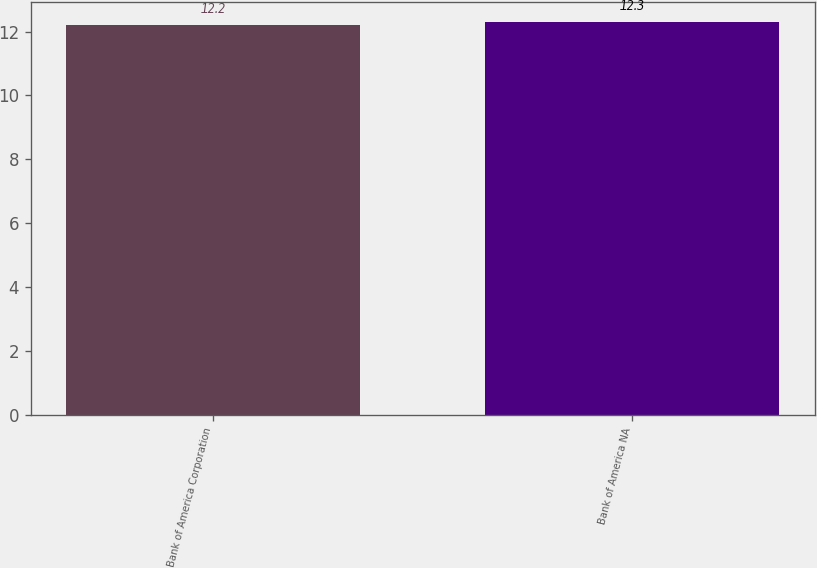Convert chart to OTSL. <chart><loc_0><loc_0><loc_500><loc_500><bar_chart><fcel>Bank of America Corporation<fcel>Bank of America NA<nl><fcel>12.2<fcel>12.3<nl></chart> 